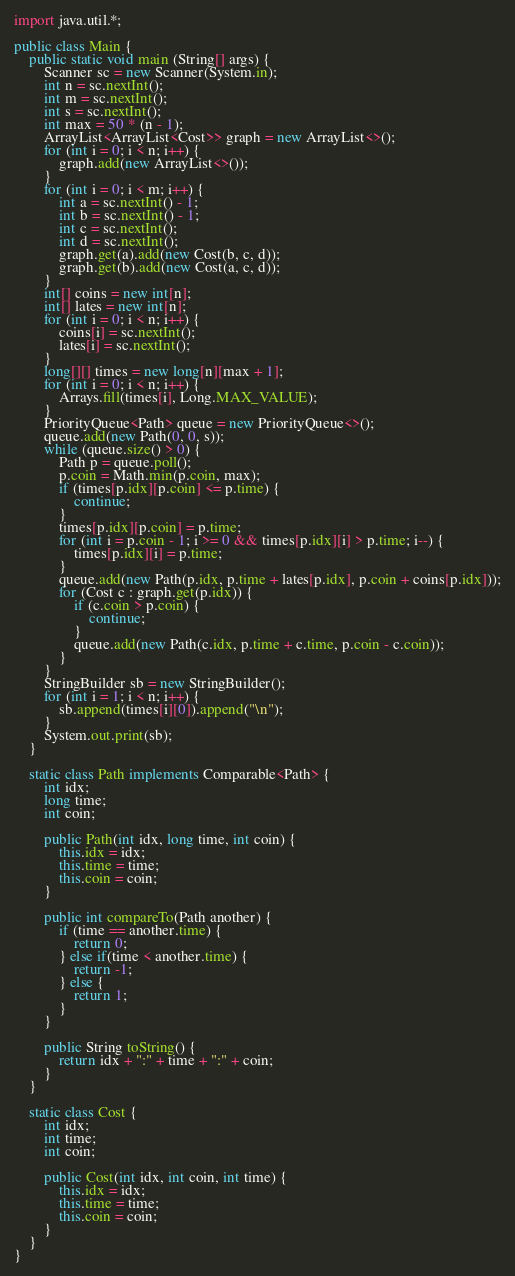<code> <loc_0><loc_0><loc_500><loc_500><_Java_>import java.util.*;

public class Main {
	public static void main (String[] args) {
		Scanner sc = new Scanner(System.in);
		int n = sc.nextInt();
		int m = sc.nextInt();
		int s = sc.nextInt();
		int max = 50 * (n - 1);
		ArrayList<ArrayList<Cost>> graph = new ArrayList<>();
		for (int i = 0; i < n; i++) {
		    graph.add(new ArrayList<>());
		}
		for (int i = 0; i < m; i++) {
		    int a = sc.nextInt() - 1;
		    int b = sc.nextInt() - 1;
		    int c = sc.nextInt();
		    int d = sc.nextInt();
		    graph.get(a).add(new Cost(b, c, d));
		    graph.get(b).add(new Cost(a, c, d));
		}
		int[] coins = new int[n];
		int[] lates = new int[n];
		for (int i = 0; i < n; i++) {
		    coins[i] = sc.nextInt();
		    lates[i] = sc.nextInt();
		}
	    long[][] times = new long[n][max + 1];
	    for (int i = 0; i < n; i++) {
	        Arrays.fill(times[i], Long.MAX_VALUE);
	    }
	    PriorityQueue<Path> queue = new PriorityQueue<>();
	    queue.add(new Path(0, 0, s));
	    while (queue.size() > 0) {
	        Path p = queue.poll();
	        p.coin = Math.min(p.coin, max);
	        if (times[p.idx][p.coin] <= p.time) {
	            continue;
	        }
	        times[p.idx][p.coin] = p.time;
	        for (int i = p.coin - 1; i >= 0 && times[p.idx][i] > p.time; i--) {
	            times[p.idx][i] = p.time;
	        }
	        queue.add(new Path(p.idx, p.time + lates[p.idx], p.coin + coins[p.idx]));
	        for (Cost c : graph.get(p.idx)) {
	            if (c.coin > p.coin) {
	                continue;
	            }
	            queue.add(new Path(c.idx, p.time + c.time, p.coin - c.coin));
	        }
	    }
	    StringBuilder sb = new StringBuilder();
	    for (int i = 1; i < n; i++) {
	        sb.append(times[i][0]).append("\n");
	    }
	    System.out.print(sb);
	}
	
	static class Path implements Comparable<Path> {
	    int idx;
	    long time;
	    int coin;
	    
	    public Path(int idx, long time, int coin) {
	        this.idx = idx;
	        this.time = time;
	        this.coin = coin;
	    }
	    
	    public int compareTo(Path another) {
	        if (time == another.time) {
	            return 0;
	        } else if(time < another.time) {
	            return -1;
	        } else {
	            return 1;
	        }
	    }
	    
	    public String toString() {
	        return idx + ":" + time + ":" + coin;
	    }
	}
	
	static class Cost {
	    int idx;
	    int time;
	    int coin;
	    
	    public Cost(int idx, int coin, int time) {
	        this.idx = idx;
	        this.time = time;
	        this.coin = coin;
	    }
	}
}

</code> 